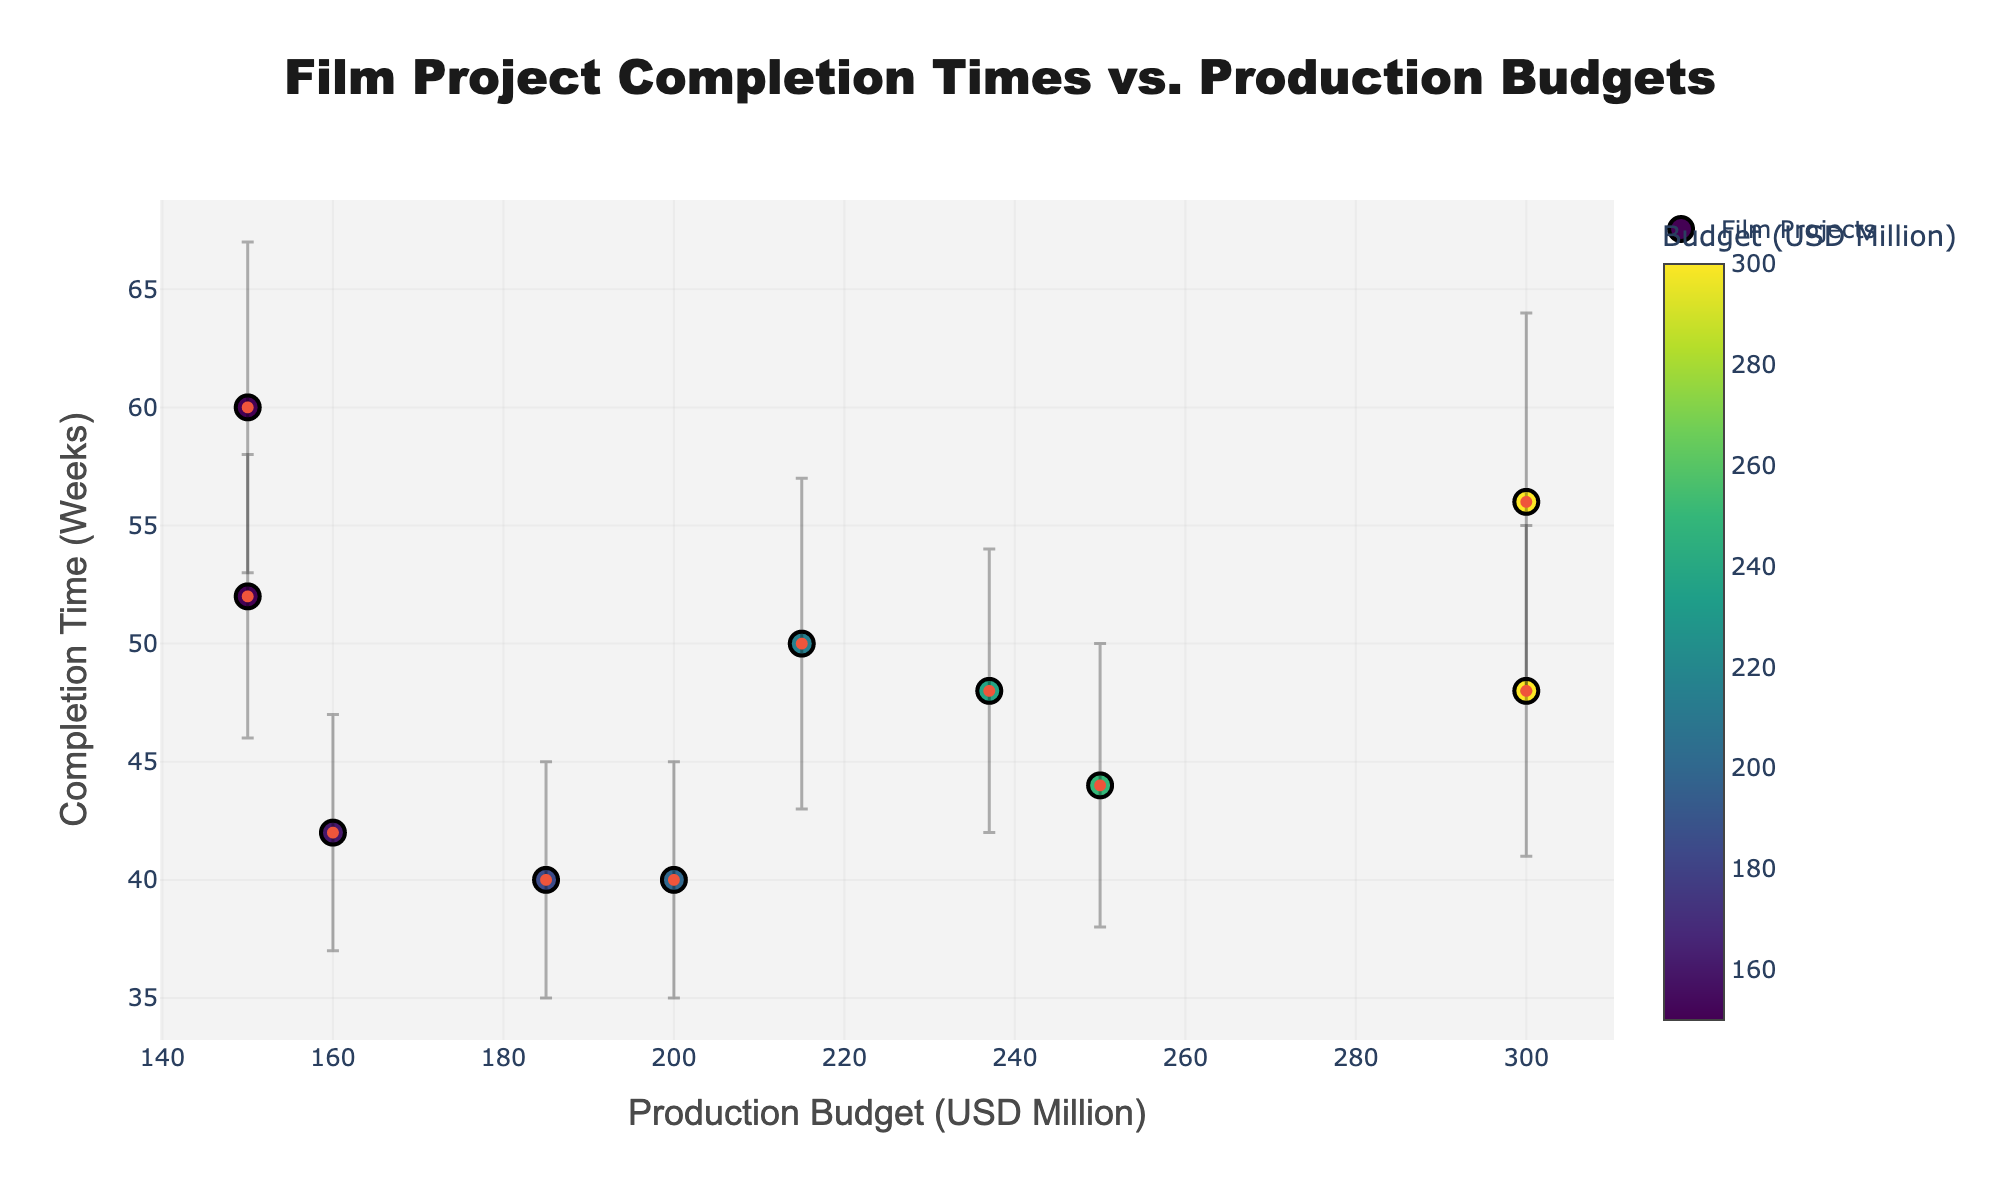How many film projects are represented in the figure? Count the number of data points on the scatter plot. Each point represents a film project.
Answer: 10 What is the title of the figure? Look at the title text displayed at the top of the plot.
Answer: Film Project Completion Times vs. Production Budgets Which film has the highest production budget? Identify the point that is furthest to the right on the x-axis and refer to the hover text to see the film name.
Answer: Pirates of the Caribbean: At World's End How many weeks did it take to complete "Avatar"? Hover over the data point for "Avatar" to check the completion time displayed in the hover text.
Answer: 48 weeks What is the range of completion times shown in the figure? Find the minimum and maximum values on the y-axis to determine the range.
Answer: 40 to 60 weeks What is the average production budget of all the films? Sum all the production budgets and then divide by the number of films (10). (150+150+185+237+160+300+300+215+250+200)/10 = 2147/10 = 214.7 million USD
Answer: 214.7 million USD Which film has the smallest confidence interval for completion time? Identify the point with the smallest vertical error bar and refer to its hover text to see the film name.
Answer: The Dark Knight Is there any film with a budget of exactly 200 million USD? Check for any point located at x = 200 on the scatter plot.
Answer: Yes, Black Panther has a budget of exactly 200 million USD Which films have the same production budget? Find points that have the same x-coordinate and refer to their hover text for the film names.
Answer: The Irishman and Mad Max: Fury Road; Pirates of the Caribbean: At World's End and Justice League Which film has the widest confidence interval for completion time? Identify the point with the largest vertical error bar and refer to its hover text to see the film name.
Answer: Pirates of the Caribbean: At World's End 